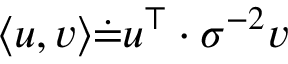<formula> <loc_0><loc_0><loc_500><loc_500>{ \langle u , v \rangle \dot { = } u ^ { \top } \cdot \sigma ^ { - 2 } v }</formula> 